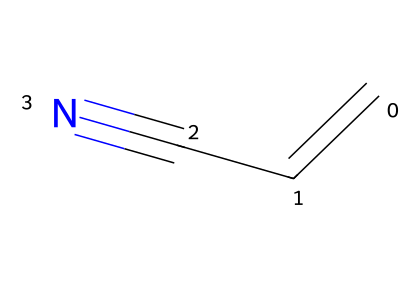What is the name of the chemical represented by this SMILES? The SMILES representation "C=CC#N" corresponds to acrylonitrile, which is the common name for this compound.
Answer: acrylonitrile How many carbon atoms are present in this molecule? The SMILES indicates there are three carbon atoms present as represented by 'C' which appears three times.
Answer: 3 What is the degree of unsaturation in acrylonitrile? The presence of a double bond (C=C) and a triple bond (C#N) contributes to the degree of unsaturation. Each double bond counts as one, and a triple bond counts as two, leading to a total of three.
Answer: 3 What functional group is present in acrylonitrile? The presence of the nitrile group (-C≡N) indicates that this compound contains a nitrile functional group.
Answer: nitrile What is the hybridization of the carbon atoms in the nitrile group? In the nitrile functional group, the carbon is connected via a triple bond to nitrogen, which is sp hybridized due to linear geometry.
Answer: sp How does the molecular structure of acrylonitrile contribute to its use in manufacturing? The structure, which includes a double bond and a highly reactive nitrile group, allows acrylonitrile to be polymerized effectively, making it useful for producing strong, resilient materials.
Answer: polymerization 